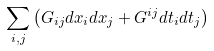Convert formula to latex. <formula><loc_0><loc_0><loc_500><loc_500>\sum _ { i , j } \left ( G _ { i j } d x _ { i } d x _ { j } + G ^ { i j } d t _ { i } d t _ { j } \right )</formula> 